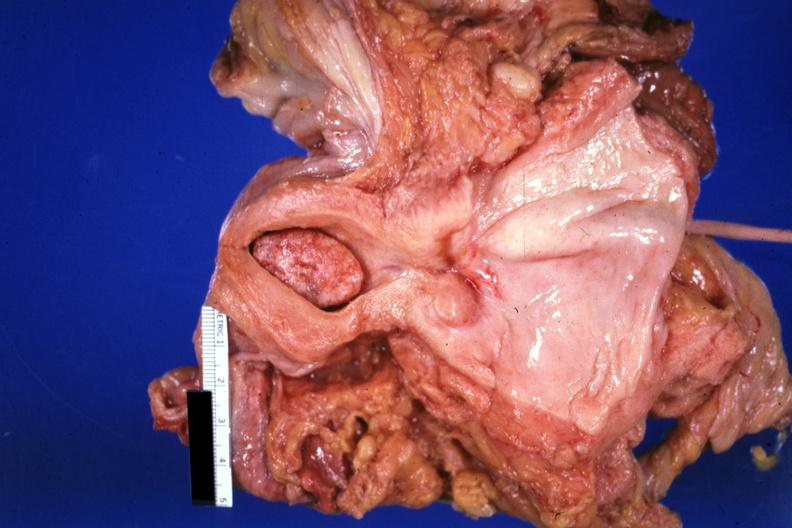what does this image show?
Answer the question using a single word or phrase. Large senile type endometrial polyp 